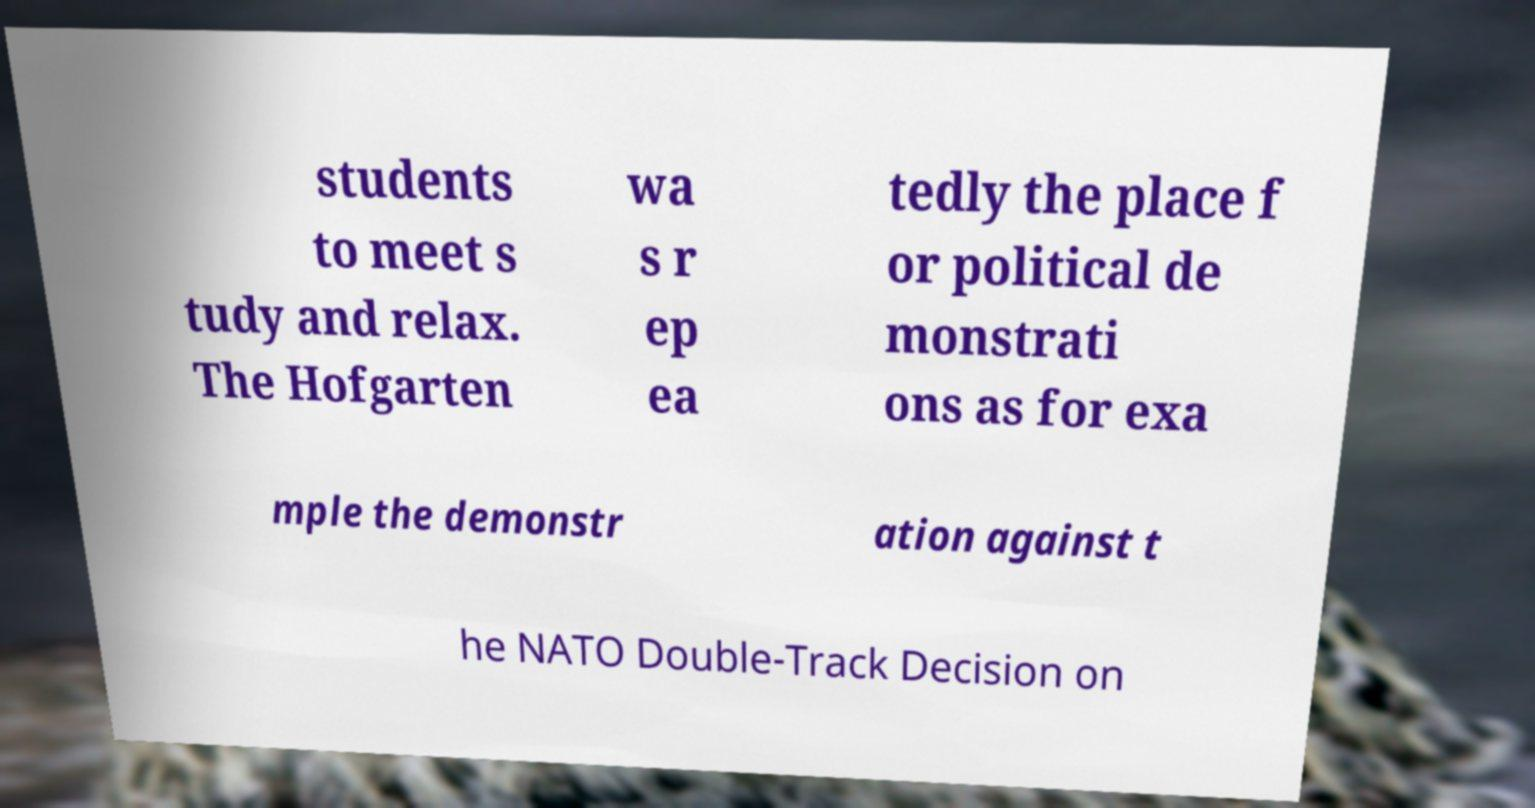I need the written content from this picture converted into text. Can you do that? students to meet s tudy and relax. The Hofgarten wa s r ep ea tedly the place f or political de monstrati ons as for exa mple the demonstr ation against t he NATO Double-Track Decision on 